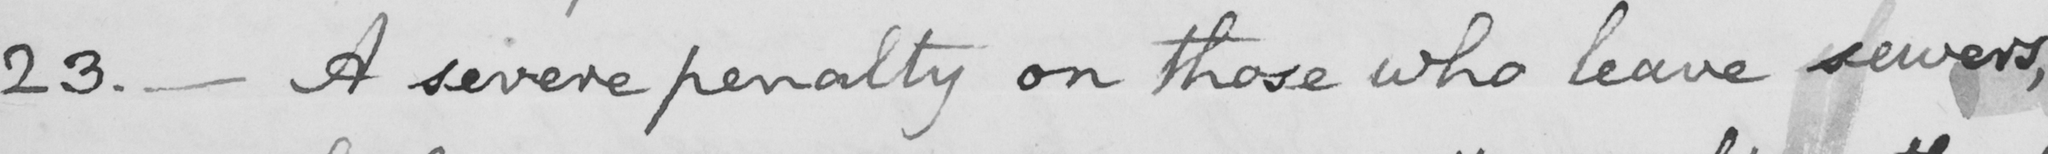What text is written in this handwritten line? 23 .  _  A severe penalty on those who leave sewers , 